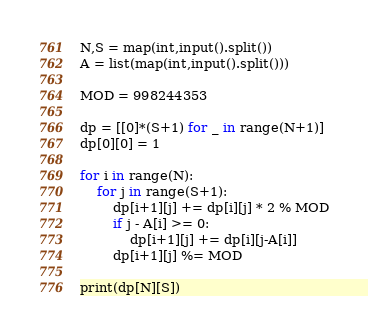<code> <loc_0><loc_0><loc_500><loc_500><_Python_>N,S = map(int,input().split())
A = list(map(int,input().split()))

MOD = 998244353

dp = [[0]*(S+1) for _ in range(N+1)]
dp[0][0] = 1

for i in range(N):
    for j in range(S+1):
        dp[i+1][j] += dp[i][j] * 2 % MOD
        if j - A[i] >= 0:
            dp[i+1][j] += dp[i][j-A[i]]
        dp[i+1][j] %= MOD
        
print(dp[N][S])</code> 